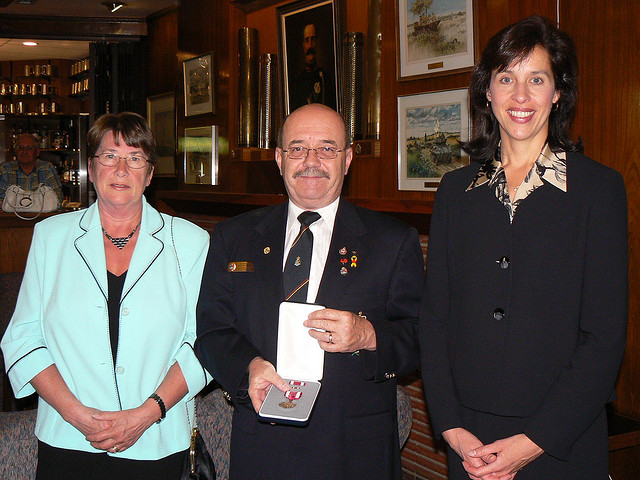What is the occasion taking place in the image? Although I'm unable to provide specific details about events, based on the attire and medals, it appears to be a formal event, possibly a ceremony or recognition event where the individual in the uniform is receiving an award or honor. 